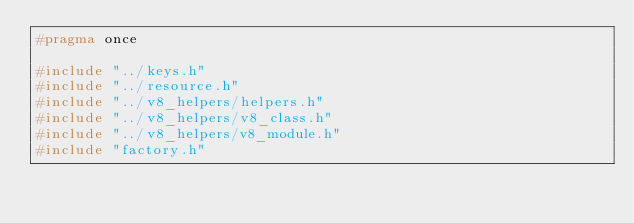Convert code to text. <code><loc_0><loc_0><loc_500><loc_500><_C_>#pragma once

#include "../keys.h"
#include "../resource.h"
#include "../v8_helpers/helpers.h"
#include "../v8_helpers/v8_class.h"
#include "../v8_helpers/v8_module.h"
#include "factory.h"
</code> 